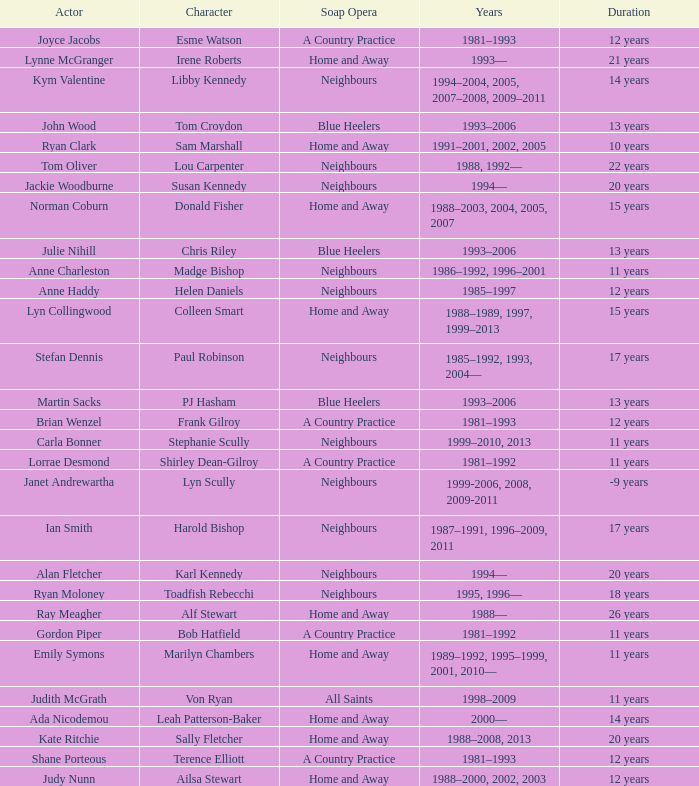Which actor played Harold Bishop for 17 years? Ian Smith. 